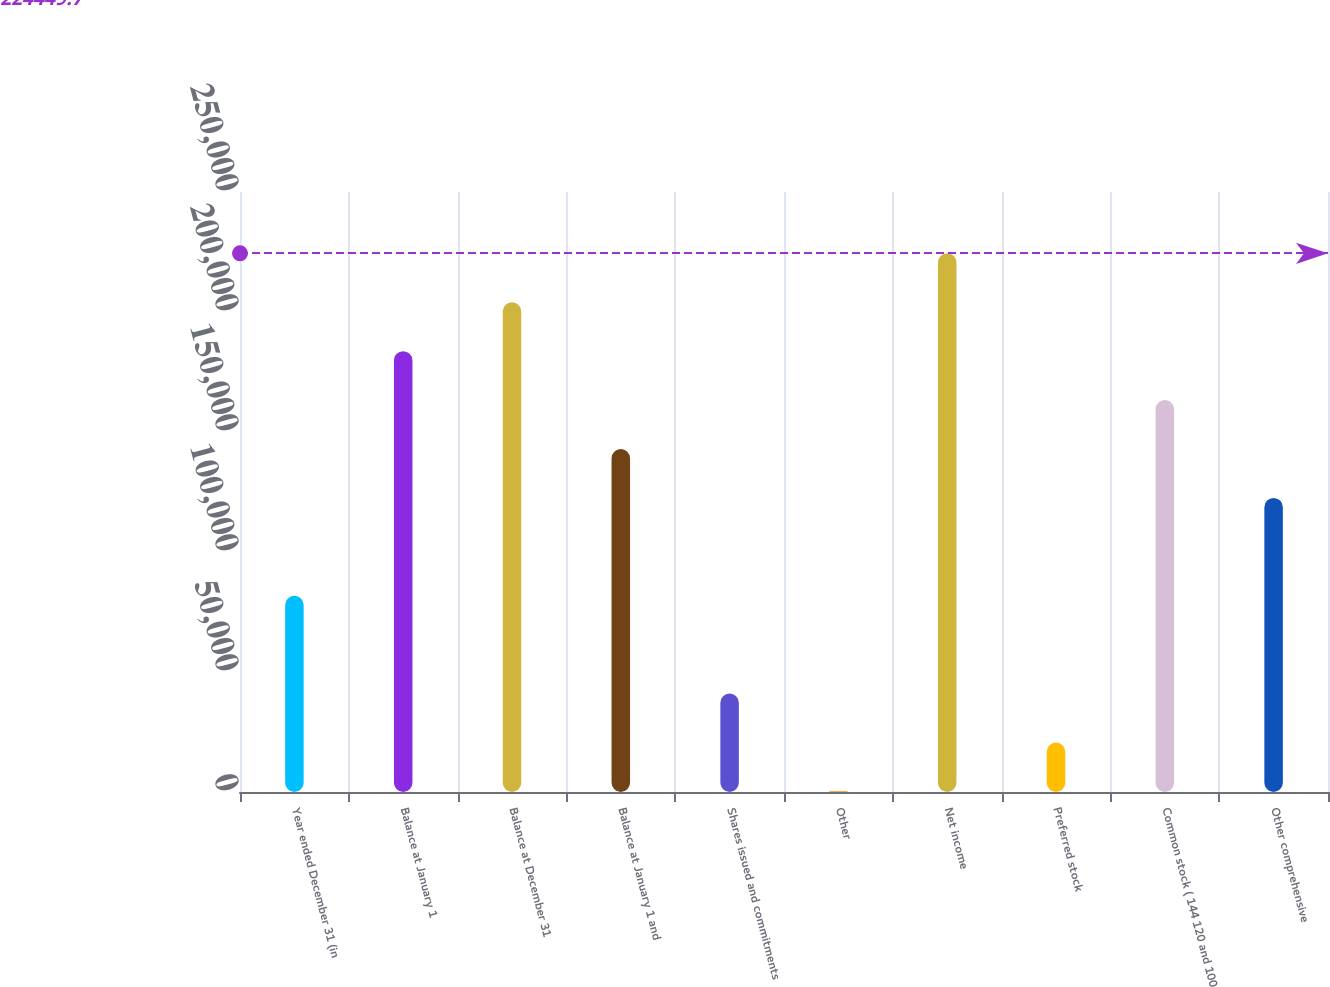<chart> <loc_0><loc_0><loc_500><loc_500><bar_chart><fcel>Year ended December 31 (in<fcel>Balance at January 1<fcel>Balance at December 31<fcel>Balance at January 1 and<fcel>Shares issued and commitments<fcel>Other<fcel>Net income<fcel>Preferred stock<fcel>Common stock ( 144 120 and 100<fcel>Other comprehensive<nl><fcel>81784.8<fcel>183688<fcel>204069<fcel>142927<fcel>41023.4<fcel>262<fcel>224450<fcel>20642.7<fcel>163308<fcel>122546<nl></chart> 